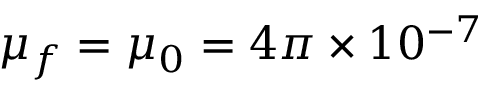<formula> <loc_0><loc_0><loc_500><loc_500>\mu _ { f } = \mu _ { 0 } = 4 \pi \times 1 0 ^ { - 7 }</formula> 